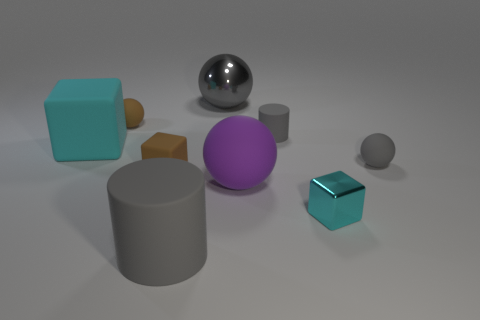What number of other objects are there of the same material as the big block?
Ensure brevity in your answer.  6. There is a purple matte sphere; how many shiny spheres are to the left of it?
Give a very brief answer. 1. Is there a large gray metallic thing?
Offer a very short reply. Yes. There is a rubber object in front of the large purple thing on the left side of the rubber thing that is on the right side of the small cyan metallic thing; what color is it?
Provide a succinct answer. Gray. There is a small brown thing in front of the tiny gray matte cylinder; is there a tiny thing that is in front of it?
Your answer should be compact. Yes. Does the cube that is to the left of the brown sphere have the same color as the small block that is to the right of the big gray matte cylinder?
Make the answer very short. Yes. What number of matte balls are the same size as the cyan matte cube?
Your answer should be compact. 1. There is a gray object that is on the right side of the shiny cube; is its size the same as the large cylinder?
Your answer should be compact. No. What shape is the small cyan metallic thing?
Offer a very short reply. Cube. What size is the other ball that is the same color as the big metallic ball?
Make the answer very short. Small. 